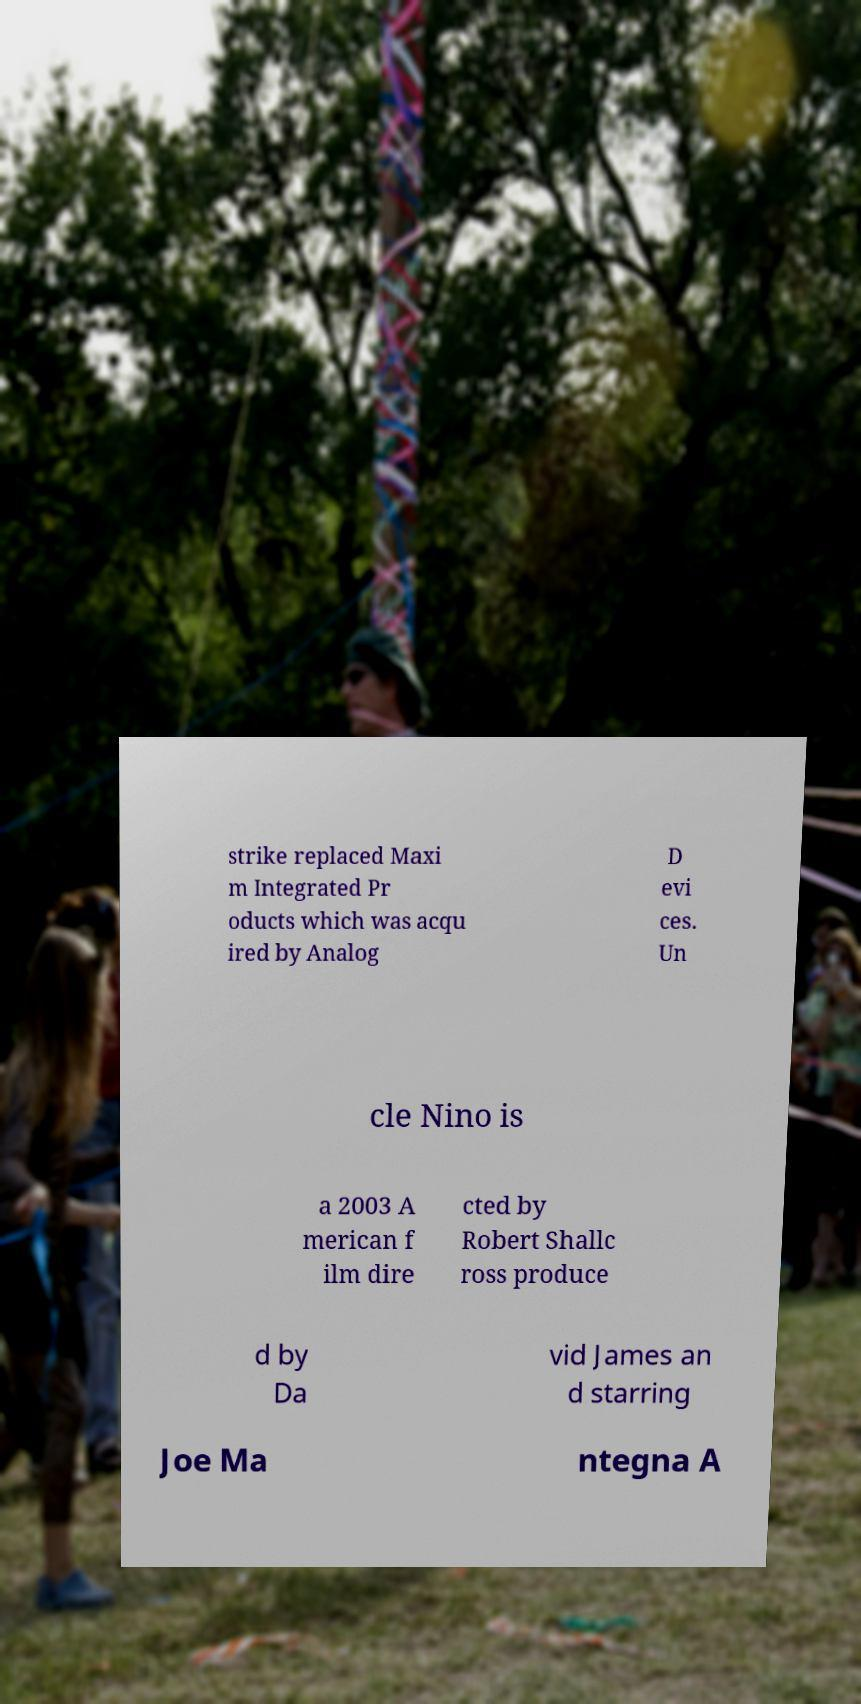For documentation purposes, I need the text within this image transcribed. Could you provide that? strike replaced Maxi m Integrated Pr oducts which was acqu ired by Analog D evi ces. Un cle Nino is a 2003 A merican f ilm dire cted by Robert Shallc ross produce d by Da vid James an d starring Joe Ma ntegna A 